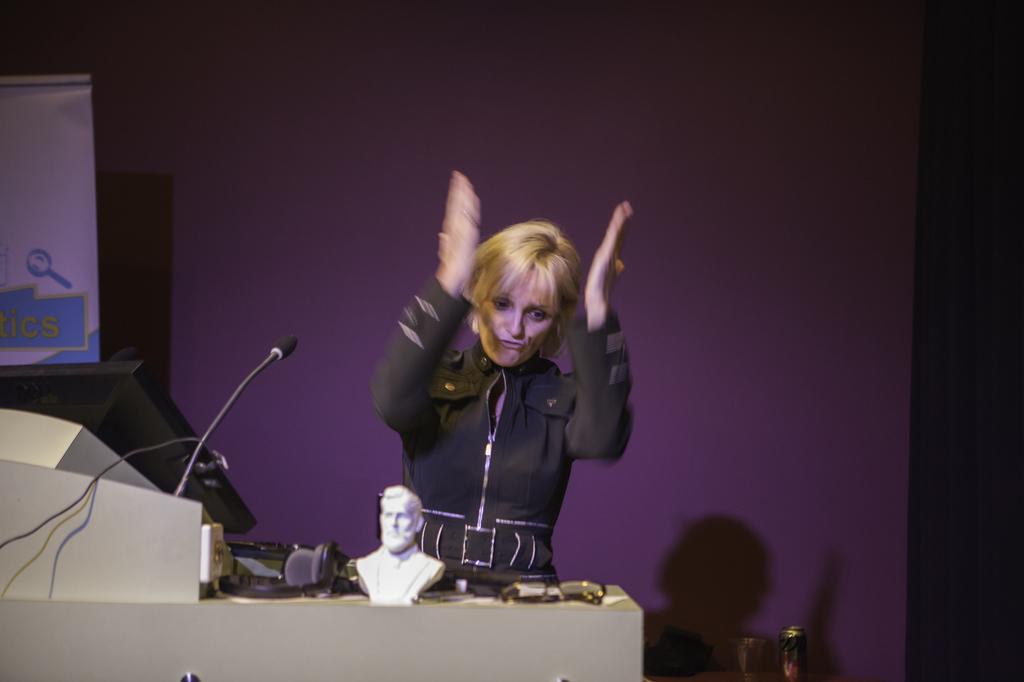Please provide a concise description of this image. In this image I can a see a lady standing, in front of her there is a table where we can see some objects and computer, behind her there is a banner on the wall. 